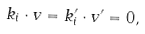<formula> <loc_0><loc_0><loc_500><loc_500>k _ { i } \cdot v = k ^ { \prime } _ { i } \cdot v ^ { \prime } = 0 ,</formula> 